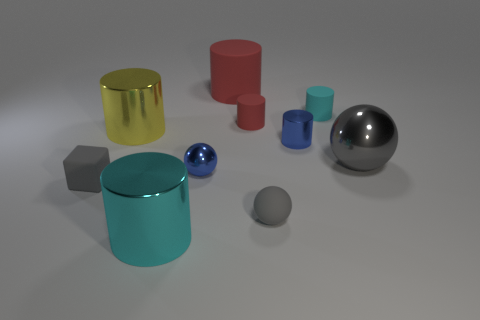Subtract all cyan cylinders. How many cylinders are left? 4 Subtract all yellow metallic cylinders. How many cylinders are left? 5 Subtract 2 cylinders. How many cylinders are left? 4 Subtract all brown cylinders. Subtract all blue blocks. How many cylinders are left? 6 Subtract all cylinders. How many objects are left? 4 Add 2 rubber cylinders. How many rubber cylinders exist? 5 Subtract 1 red cylinders. How many objects are left? 9 Subtract all small metal spheres. Subtract all gray matte balls. How many objects are left? 8 Add 3 big things. How many big things are left? 7 